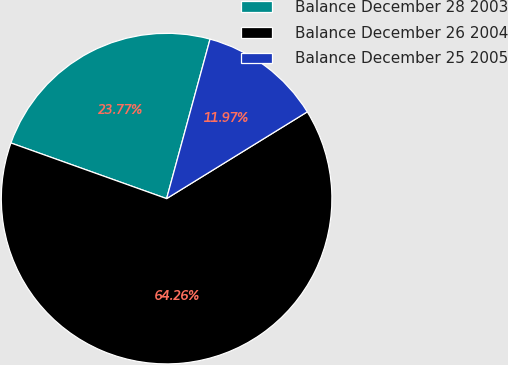Convert chart to OTSL. <chart><loc_0><loc_0><loc_500><loc_500><pie_chart><fcel>Balance December 28 2003<fcel>Balance December 26 2004<fcel>Balance December 25 2005<nl><fcel>23.77%<fcel>64.26%<fcel>11.97%<nl></chart> 